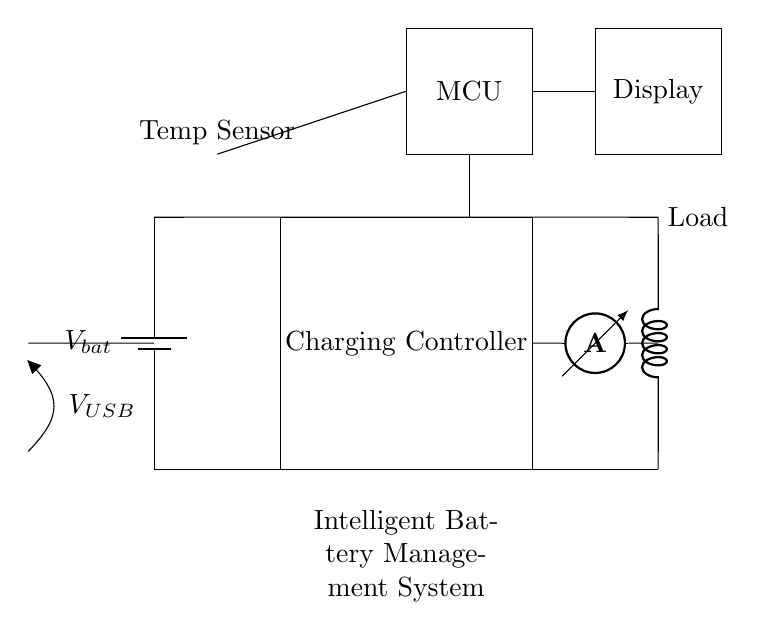What type of battery is used in this circuit? The circuit diagram illustrates a battery labeled as "V_bat," indicating it is a standard battery typically used for portable power applications.
Answer: Battery What is the purpose of the charging controller in this circuit? The charging controller regulates the flow of current from the USB input to the battery and ensures safe charging. It prevents overcharging and protects the battery's lifespan.
Answer: Regulates current What voltage does the USB input provide? The circuit has a voltage source labeled "V_USB," which is commonly associated with USB connections that typically provide a voltage of 5 volts.
Answer: 5 volts What does the microcontroller manage in this circuit? The microcontroller receives sensor input, including battery status and temperature readings, and controls the charging process and output delivery to the load.
Answer: Charging process How is temperature measured in the system? The circuit includes a temperature sensor connected to the microcontroller, which allows it to monitor the battery's temperature to prevent overheating during charging.
Answer: Thermistor What component is used to measure current in this circuit? The component designated as an "ammeter" is used to measure the current flowing through the circuit, providing feedback to the microcontroller for battery management.
Answer: Ammeter What is the load connected to in this circuit? The load is depicted as a cute inductor, representing the device that will receive power from the battery management system.
Answer: Inductor 